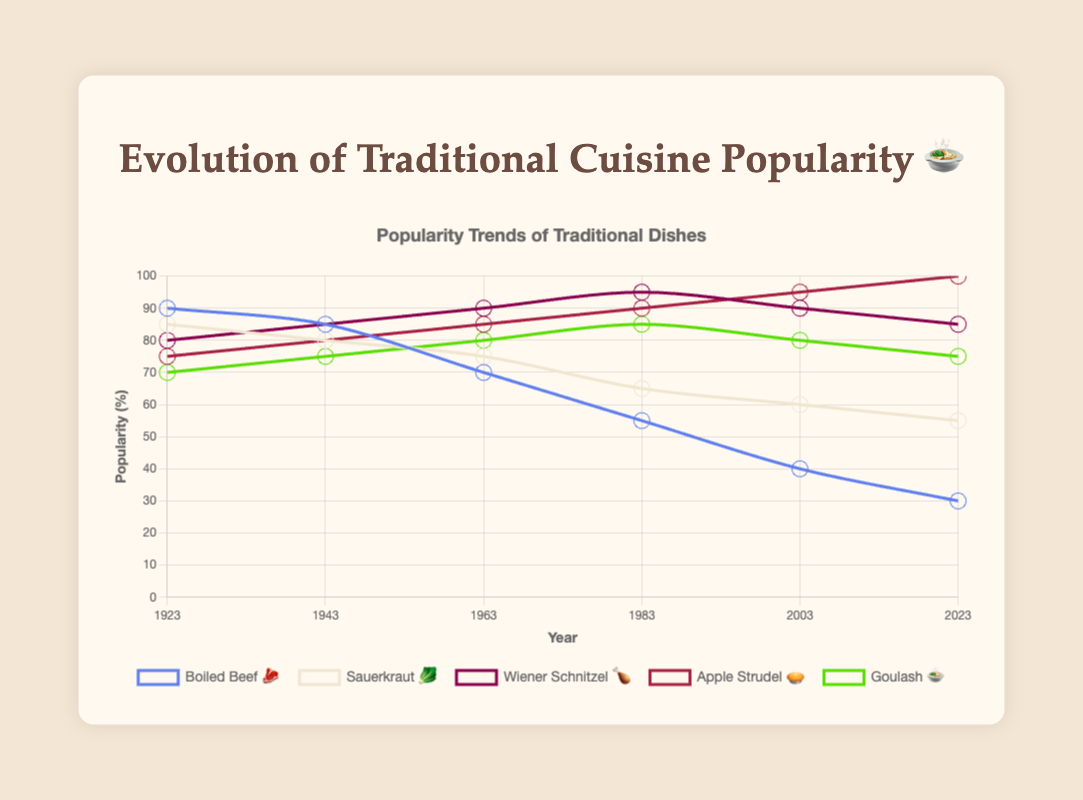What is the title of the figure? The title of the figure is written at the top and provides an overview of what the chart is about.
Answer: Evolution of Traditional Cuisine Popularity 🍲 How many years are represented on the x-axis? The x-axis shows the number of years being analyzed in the figure. Count the years listed.
Answer: 6 Which dish was consistently increasing in popularity over time? To determine this, look at the trend lines for each dish and identify which one continuously rises.
Answer: Apple Strudel 🥧 What is the popularity of "Boiled Beef 🥩" in 1963? Find the point on the line representing "Boiled Beef 🥩" that corresponds to the year 1963 and read the value.
Answer: 70 Which dish reached the highest popularity in 2023? Look at the data points for the year 2023 and determine which dish has the highest value.
Answer: Apple Strudel 🥧 What is the trend for "Wiener Schnitzel 🍗" from 1943 to 1983? Observe the line for "Wiener Schnitzel 🍗" between the years 1943 and 1983 and describe the direction of change.
Answer: Increasing Which two dishes have the closest popularity percentages in 2023? Compare the final data points for each dish in 2023 and find the two that are nearest in value.
Answer: Sauerkraut 🥬 and Goulash 🍲 Calculate the average popularity of "Sauerkraut 🥬" over the 100 years. Sum the popularity values for "Sauerkraut 🥬" across all years, then divide by the number of data points (6).
Answer: (85+80+75+65+60+55)/6 = 70 Which dish had the largest drop in popularity from 1923 to 2023? Subtract the 1923 value from the 2023 value for each dish, and identify the one with the largest decrease.
Answer: Boiled Beef 🥩 In which decade did "Goulash 🍲" see a decline in popularity? Examine the trend line for "Goulash 🍲" and determine the decade(s) where the popularity decreased.
Answer: 2003 to 2023 What is the difference in popularity between "Apple Strudel 🥧" and "Boiled Beef 🥩" in 2023? Subtract the 2023 value for "Boiled Beef 🥩" from the 2023 value for "Apple Strudel 🥧".
Answer: 100 - 30 = 70 